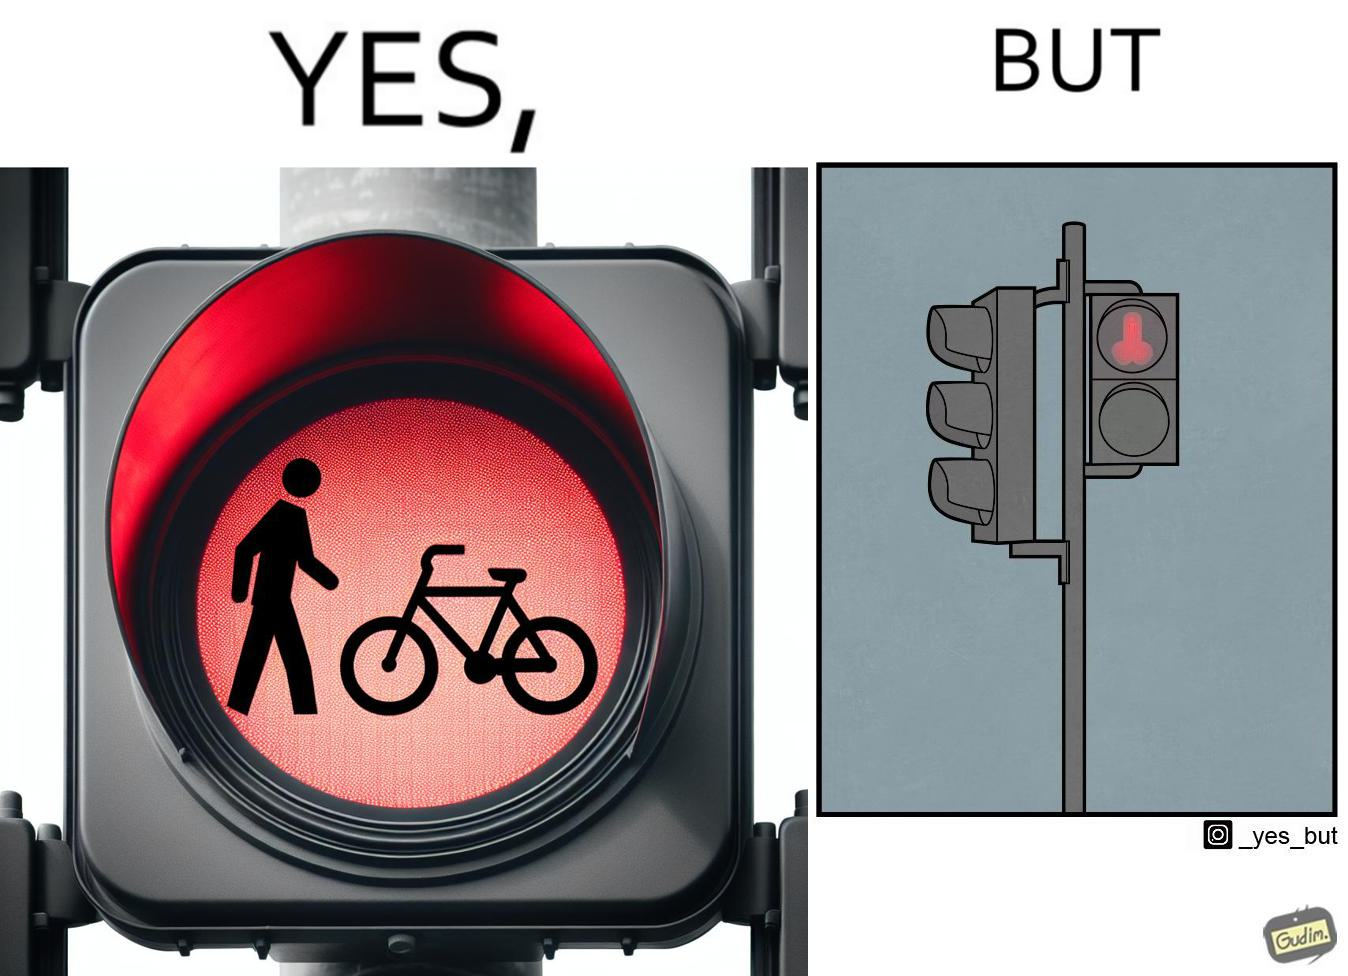Provide a description of this image. This image is funny because images of very regular things - a stick figure and a bicycle, get converted into  looking phallic from a distance. 